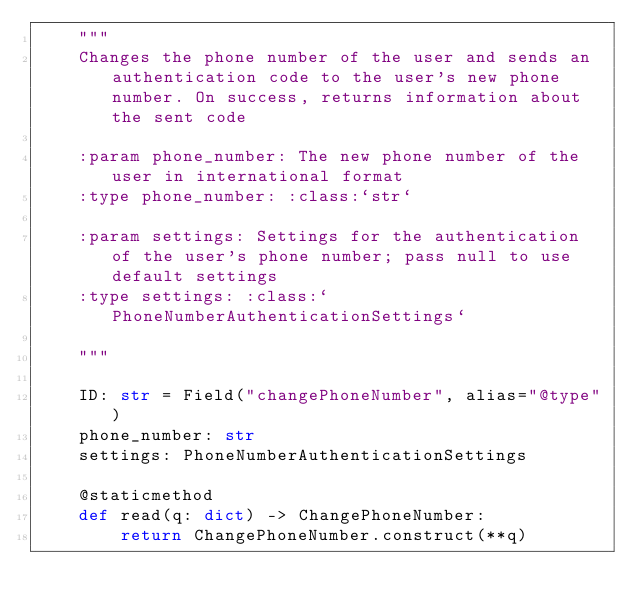Convert code to text. <code><loc_0><loc_0><loc_500><loc_500><_Python_>    """
    Changes the phone number of the user and sends an authentication code to the user's new phone number. On success, returns information about the sent code
    
    :param phone_number: The new phone number of the user in international format
    :type phone_number: :class:`str`
    
    :param settings: Settings for the authentication of the user's phone number; pass null to use default settings
    :type settings: :class:`PhoneNumberAuthenticationSettings`
    
    """

    ID: str = Field("changePhoneNumber", alias="@type")
    phone_number: str
    settings: PhoneNumberAuthenticationSettings

    @staticmethod
    def read(q: dict) -> ChangePhoneNumber:
        return ChangePhoneNumber.construct(**q)
</code> 